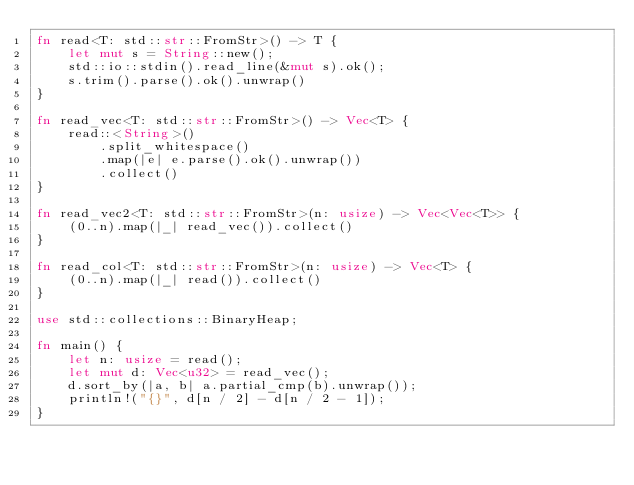<code> <loc_0><loc_0><loc_500><loc_500><_Rust_>fn read<T: std::str::FromStr>() -> T {
    let mut s = String::new();
    std::io::stdin().read_line(&mut s).ok();
    s.trim().parse().ok().unwrap()
}

fn read_vec<T: std::str::FromStr>() -> Vec<T> {
    read::<String>()
        .split_whitespace()
        .map(|e| e.parse().ok().unwrap())
        .collect()
}

fn read_vec2<T: std::str::FromStr>(n: usize) -> Vec<Vec<T>> {
    (0..n).map(|_| read_vec()).collect()
}

fn read_col<T: std::str::FromStr>(n: usize) -> Vec<T> {
    (0..n).map(|_| read()).collect()
}

use std::collections::BinaryHeap;

fn main() {
    let n: usize = read();
    let mut d: Vec<u32> = read_vec();
    d.sort_by(|a, b| a.partial_cmp(b).unwrap());
    println!("{}", d[n / 2] - d[n / 2 - 1]);
}
</code> 